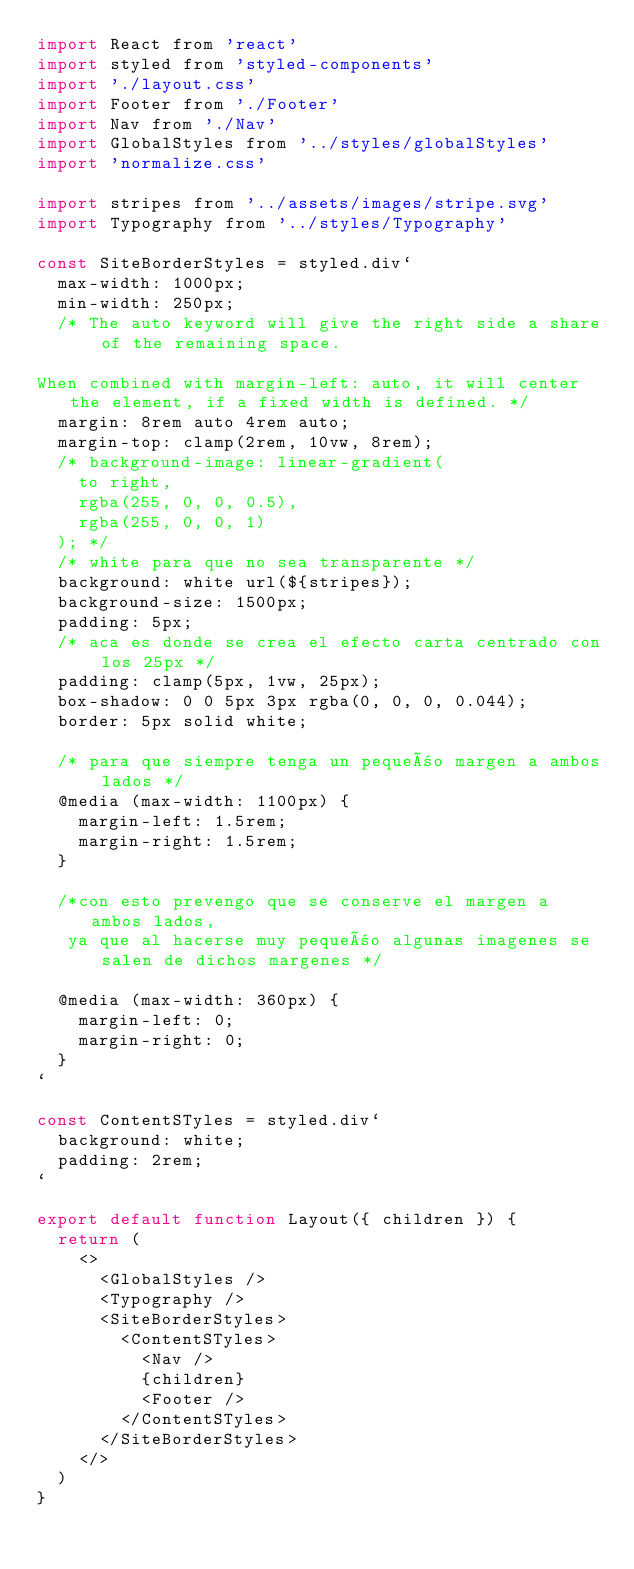<code> <loc_0><loc_0><loc_500><loc_500><_JavaScript_>import React from 'react'
import styled from 'styled-components'
import './layout.css'
import Footer from './Footer'
import Nav from './Nav'
import GlobalStyles from '../styles/globalStyles'
import 'normalize.css'

import stripes from '../assets/images/stripe.svg'
import Typography from '../styles/Typography'

const SiteBorderStyles = styled.div`
  max-width: 1000px;
  min-width: 250px;
  /* The auto keyword will give the right side a share of the remaining space.

When combined with margin-left: auto, it will center the element, if a fixed width is defined. */
  margin: 8rem auto 4rem auto;
  margin-top: clamp(2rem, 10vw, 8rem);
  /* background-image: linear-gradient(
    to right,
    rgba(255, 0, 0, 0.5),
    rgba(255, 0, 0, 1)
  ); */
  /* white para que no sea transparente */
  background: white url(${stripes});
  background-size: 1500px;
  padding: 5px;
  /* aca es donde se crea el efecto carta centrado con los 25px */
  padding: clamp(5px, 1vw, 25px);
  box-shadow: 0 0 5px 3px rgba(0, 0, 0, 0.044);
  border: 5px solid white;

  /* para que siempre tenga un pequeño margen a ambos lados */
  @media (max-width: 1100px) {
    margin-left: 1.5rem;
    margin-right: 1.5rem;
  }

  /*con esto prevengo que se conserve el margen a ambos lados,
   ya que al hacerse muy pequeño algunas imagenes se salen de dichos margenes */

  @media (max-width: 360px) {
    margin-left: 0;
    margin-right: 0;
  }
`

const ContentSTyles = styled.div`
  background: white;
  padding: 2rem;
`

export default function Layout({ children }) {
  return (
    <>
      <GlobalStyles />
      <Typography />
      <SiteBorderStyles>
        <ContentSTyles>
          <Nav />
          {children}
          <Footer />
        </ContentSTyles>
      </SiteBorderStyles>
    </>
  )
}
</code> 